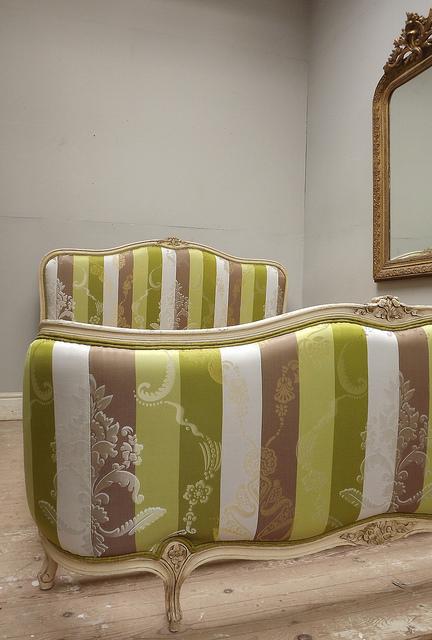What pattern is the piece of furniture?
Concise answer only. Striped. How many colors is the furniture?
Concise answer only. 4. What is the bed frame made of?
Short answer required. Wood. What is on the wall?
Answer briefly. Mirror. 